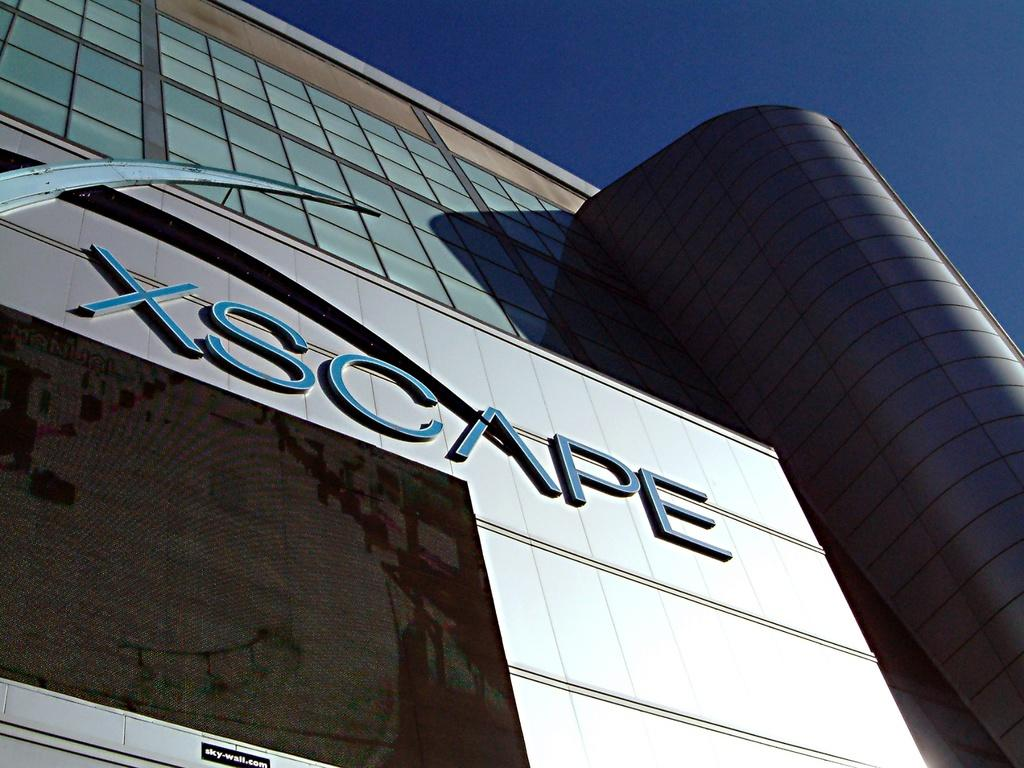What type of structure is present in the image? There is a building in the image. What can be seen on the building? The building has text on it. What is visible in the background of the image? The sky is visible in the background of the image. What type of rice is being cooked in the image? There is no rice present in the image; it features a building with text and a visible sky in the background. 